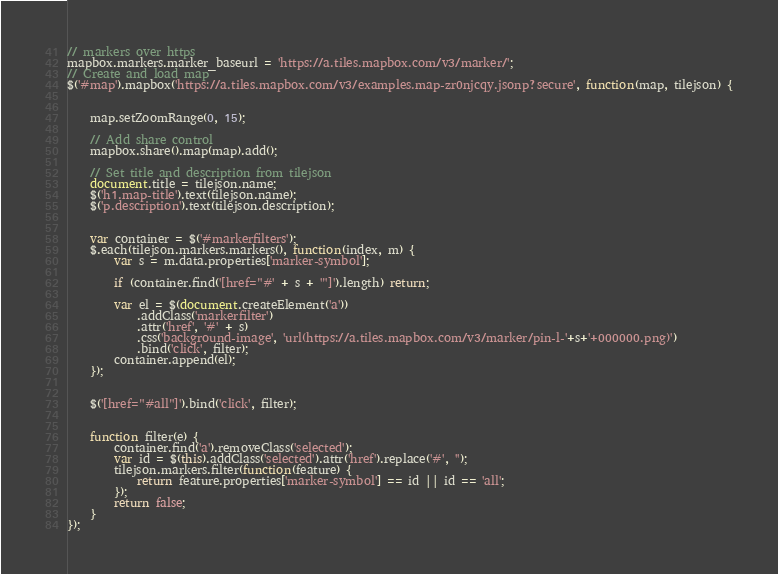Convert code to text. <code><loc_0><loc_0><loc_500><loc_500><_JavaScript_>// markers over https
mapbox.markers.marker_baseurl = 'https://a.tiles.mapbox.com/v3/marker/';
// Create and load map
$('#map').mapbox('https://a.tiles.mapbox.com/v3/examples.map-zr0njcqy.jsonp?secure', function(map, tilejson) {


    map.setZoomRange(0, 15);

    // Add share control
    mapbox.share().map(map).add();

    // Set title and description from tilejson
    document.title = tilejson.name;
    $('h1.map-title').text(tilejson.name);
    $('p.description').text(tilejson.description);


    var container = $('#markerfilters');
    $.each(tilejson.markers.markers(), function(index, m) {
        var s = m.data.properties['marker-symbol'];

        if (container.find('[href="#' + s + '"]').length) return;

        var el = $(document.createElement('a'))
            .addClass('markerfilter')
            .attr('href', '#' + s)
            .css('background-image', 'url(https://a.tiles.mapbox.com/v3/marker/pin-l-'+s+'+000000.png)')
            .bind('click', filter);
        container.append(el);
    });


    $('[href="#all"]').bind('click', filter);


    function filter(e) {
        container.find('a').removeClass('selected');
        var id = $(this).addClass('selected').attr('href').replace('#', '');
        tilejson.markers.filter(function(feature) {
            return feature.properties['marker-symbol'] == id || id == 'all';
        });
        return false;
    }
});
</code> 